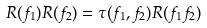<formula> <loc_0><loc_0><loc_500><loc_500>R ( f _ { 1 } ) R ( f _ { 2 } ) = \tau ( f _ { 1 } , f _ { 2 } ) R ( f _ { 1 } f _ { 2 } )</formula> 